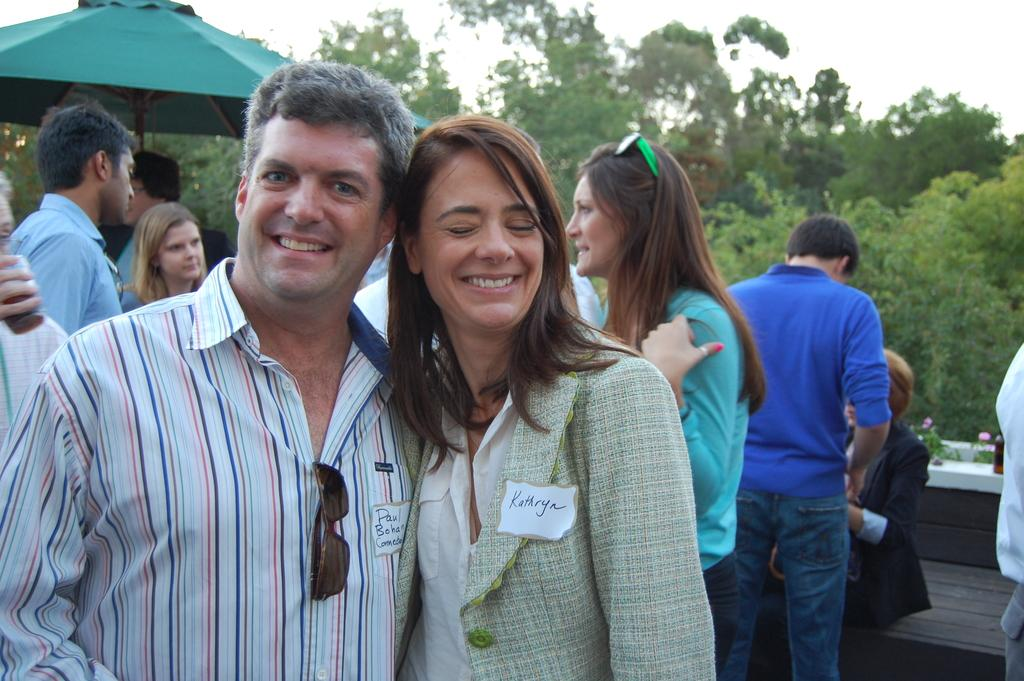Who or what can be seen in the image? There are people in the image. What type of natural elements are present in the image? There are trees and plants with flowers in the image. What objects can be seen in the image? There is a bottle and an umbrella in the image. What is visible in the background of the image? The sky is visible in the background of the image. What type of fowl can be seen wearing apparel in the image? There is no fowl present in the image, let alone one wearing apparel. 